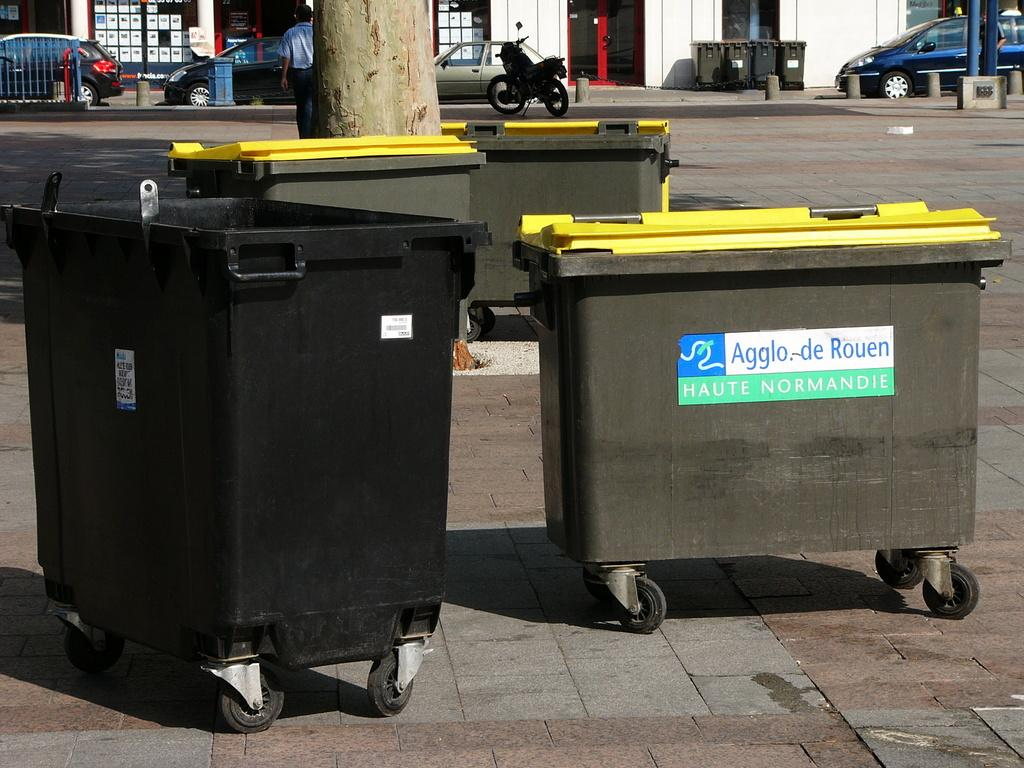<image>
Share a concise interpretation of the image provided. A dumpster with a sign that reads Agglo.-de Rouen. 